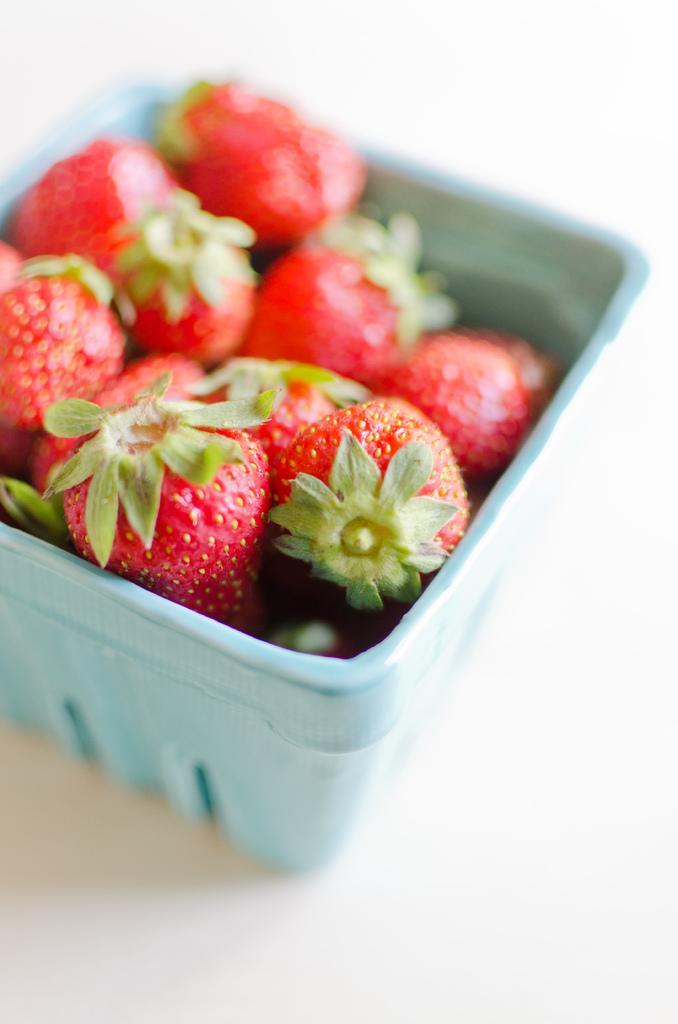Please provide a concise description of this image. In this image, there are strawberries in the box placed on the table. 